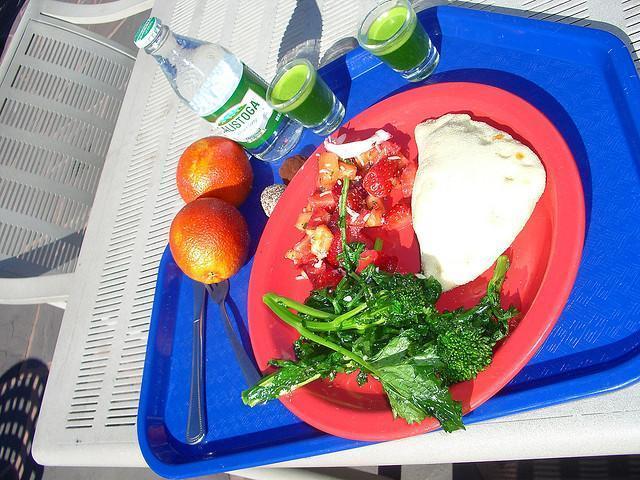How many cups are in the picture?
Give a very brief answer. 2. How many oranges can you see?
Give a very brief answer. 2. How many chairs are there?
Give a very brief answer. 1. 